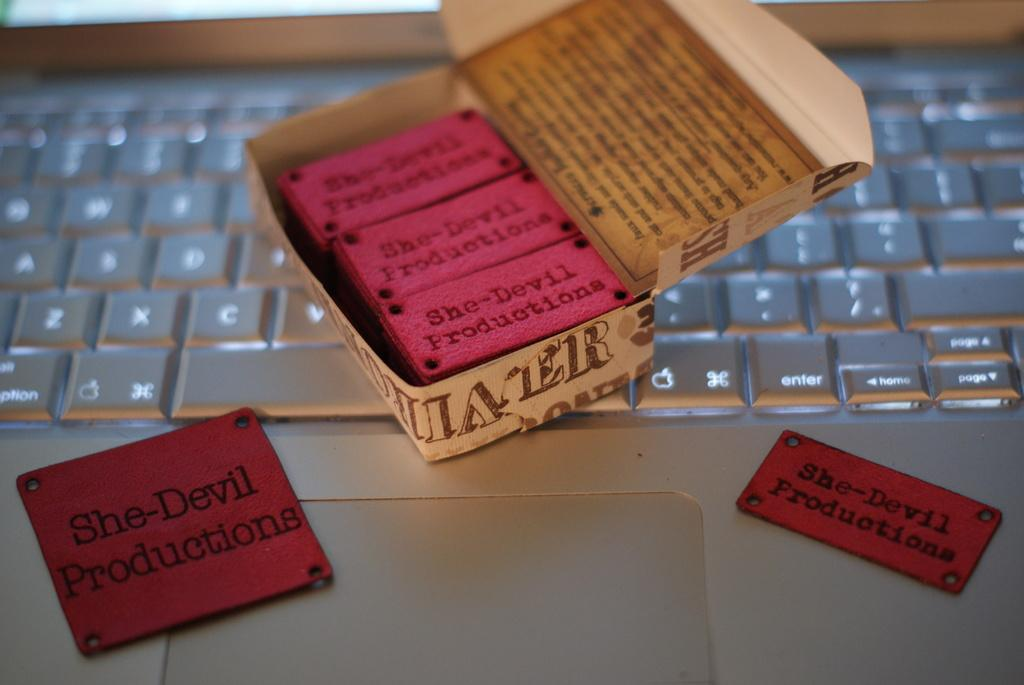<image>
Give a short and clear explanation of the subsequent image. A case of stickers that say She-Devil Productions rests on top of a keyboard. 